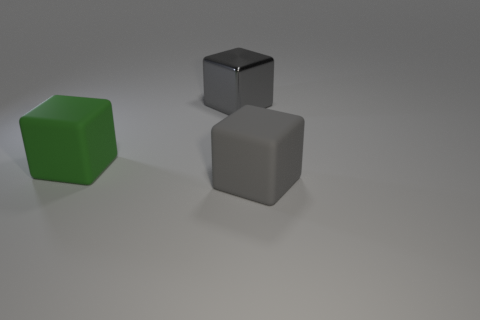Subtract all green cylinders. How many gray blocks are left? 2 Subtract all gray metal cubes. How many cubes are left? 2 Add 1 big gray rubber objects. How many objects exist? 4 Add 1 big rubber blocks. How many big rubber blocks are left? 3 Add 1 large gray blocks. How many large gray blocks exist? 3 Subtract 0 yellow balls. How many objects are left? 3 Subtract all gray rubber things. Subtract all matte objects. How many objects are left? 0 